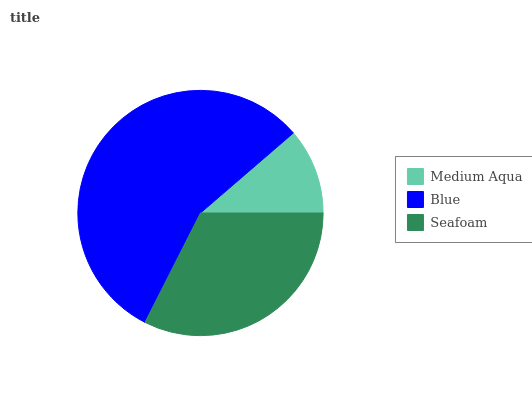Is Medium Aqua the minimum?
Answer yes or no. Yes. Is Blue the maximum?
Answer yes or no. Yes. Is Seafoam the minimum?
Answer yes or no. No. Is Seafoam the maximum?
Answer yes or no. No. Is Blue greater than Seafoam?
Answer yes or no. Yes. Is Seafoam less than Blue?
Answer yes or no. Yes. Is Seafoam greater than Blue?
Answer yes or no. No. Is Blue less than Seafoam?
Answer yes or no. No. Is Seafoam the high median?
Answer yes or no. Yes. Is Seafoam the low median?
Answer yes or no. Yes. Is Medium Aqua the high median?
Answer yes or no. No. Is Medium Aqua the low median?
Answer yes or no. No. 